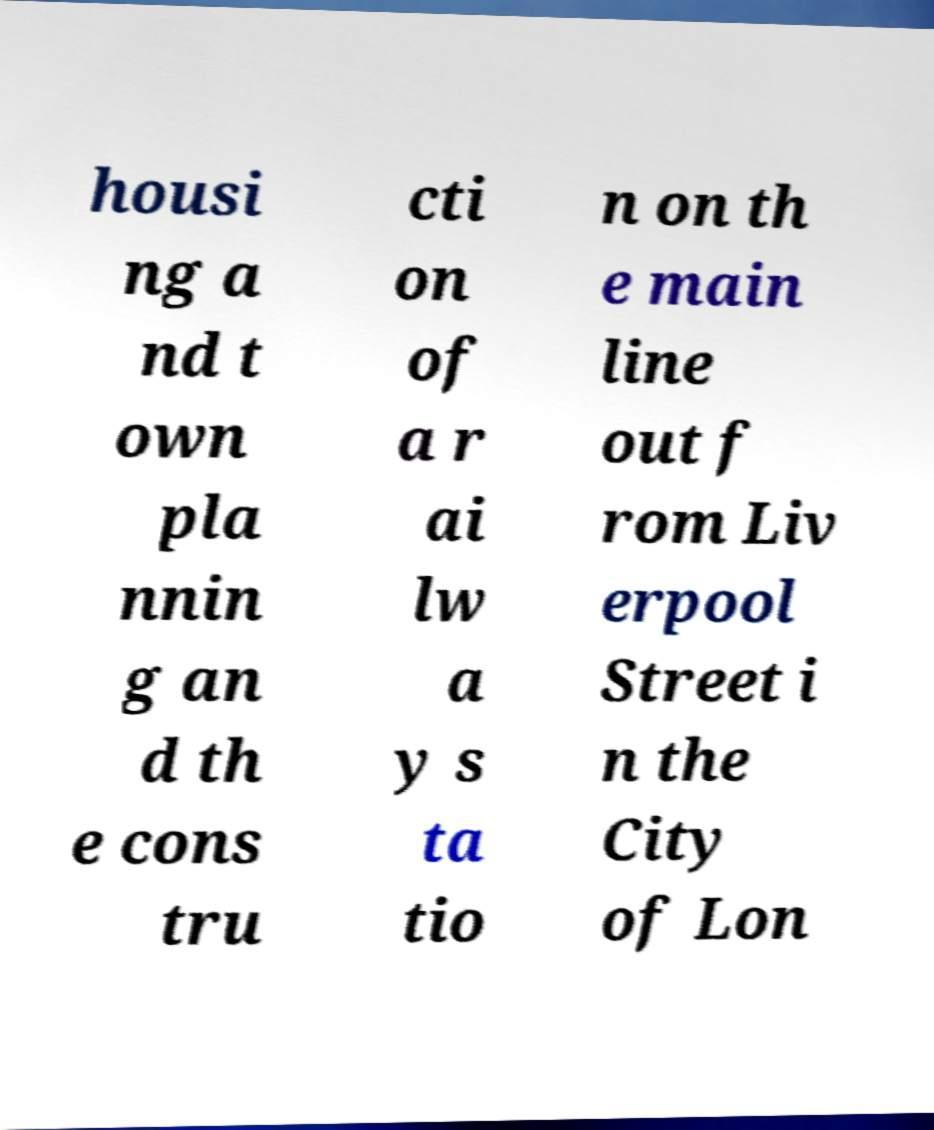Could you assist in decoding the text presented in this image and type it out clearly? housi ng a nd t own pla nnin g an d th e cons tru cti on of a r ai lw a y s ta tio n on th e main line out f rom Liv erpool Street i n the City of Lon 